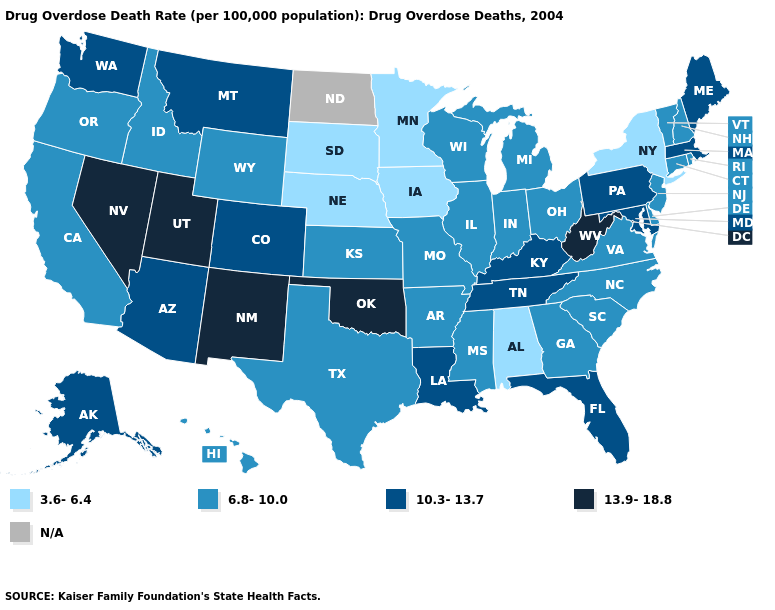What is the highest value in states that border Florida?
Concise answer only. 6.8-10.0. Does the map have missing data?
Short answer required. Yes. Name the states that have a value in the range 13.9-18.8?
Give a very brief answer. Nevada, New Mexico, Oklahoma, Utah, West Virginia. Name the states that have a value in the range 6.8-10.0?
Write a very short answer. Arkansas, California, Connecticut, Delaware, Georgia, Hawaii, Idaho, Illinois, Indiana, Kansas, Michigan, Mississippi, Missouri, New Hampshire, New Jersey, North Carolina, Ohio, Oregon, Rhode Island, South Carolina, Texas, Vermont, Virginia, Wisconsin, Wyoming. Does the map have missing data?
Quick response, please. Yes. Name the states that have a value in the range 6.8-10.0?
Answer briefly. Arkansas, California, Connecticut, Delaware, Georgia, Hawaii, Idaho, Illinois, Indiana, Kansas, Michigan, Mississippi, Missouri, New Hampshire, New Jersey, North Carolina, Ohio, Oregon, Rhode Island, South Carolina, Texas, Vermont, Virginia, Wisconsin, Wyoming. Among the states that border Ohio , does Michigan have the lowest value?
Keep it brief. Yes. What is the lowest value in the USA?
Short answer required. 3.6-6.4. Does the first symbol in the legend represent the smallest category?
Be succinct. Yes. Does Kansas have the lowest value in the MidWest?
Quick response, please. No. Among the states that border Illinois , which have the lowest value?
Give a very brief answer. Iowa. What is the value of Oklahoma?
Concise answer only. 13.9-18.8. What is the value of South Dakota?
Give a very brief answer. 3.6-6.4. Which states have the highest value in the USA?
Short answer required. Nevada, New Mexico, Oklahoma, Utah, West Virginia. 